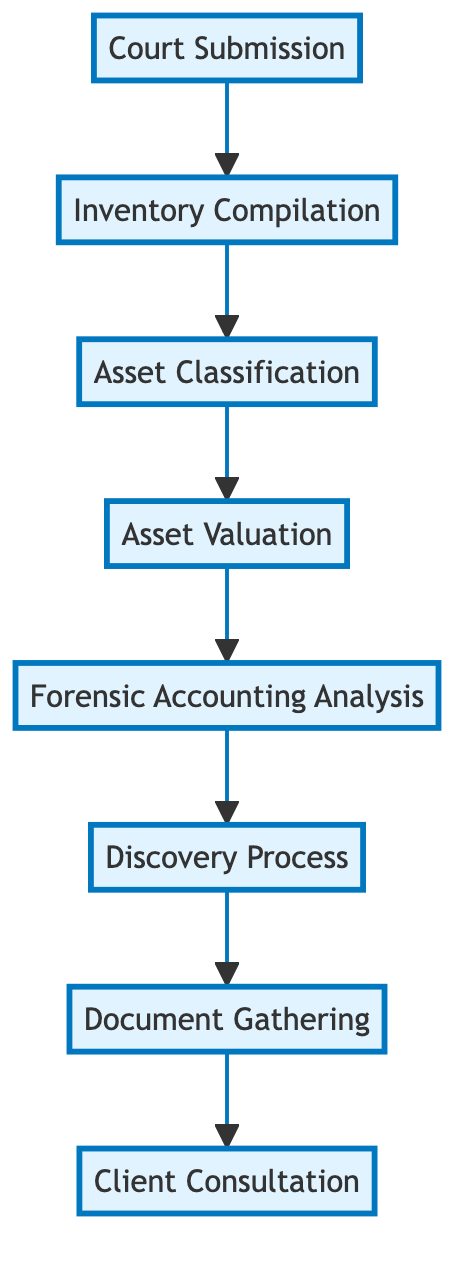What is the first step in the asset identification process? The first step in the flowchart is "Client Consultation", which is indicated as the bottom-most element.
Answer: Client Consultation How many total steps are included in the asset identification process? By counting each step in the flowchart from "Client Consultation" to "Court Submission", there are eight distinct steps listed.
Answer: 8 What is the immediate step that follows "Document Gathering"? According to the flow, "Document Gathering" is followed directly by "Discovery Process", as indicated by the arrow connecting the two.
Answer: Discovery Process What type of analysis is conducted after the "Discovery Process"? The flowchart depicts that after the "Discovery Process", the next step is "Forensic Accounting Analysis".
Answer: Forensic Accounting Analysis Which step involves submitting the inventory to the court? The last step at the top of the flowchart is "Court Submission", which specifically mentions submitting the compiled inventory.
Answer: Court Submission What is the purpose of the "Asset Classification" step? "Asset Classification" serves to categorize assets into marital and separate property, as described in the flowchart description of that step.
Answer: Categorizing assets How many steps are there between "Client Consultation" and "Court Submission"? There are six steps that flow upward from "Client Consultation" to "Court Submission" when counting the steps in between the two nodes.
Answer: 6 What step follows "Asset Valuation" in the process? Directly above "Asset Valuation" in the flow diagram is the "Asset Classification" step, which comes next in the sequence.
Answer: Asset Classification What is the last action taken in the asset identification process? The flowchart indicates that the last action, or step, is "Court Submission", marking the conclusion of the asset identification process.
Answer: Court Submission 